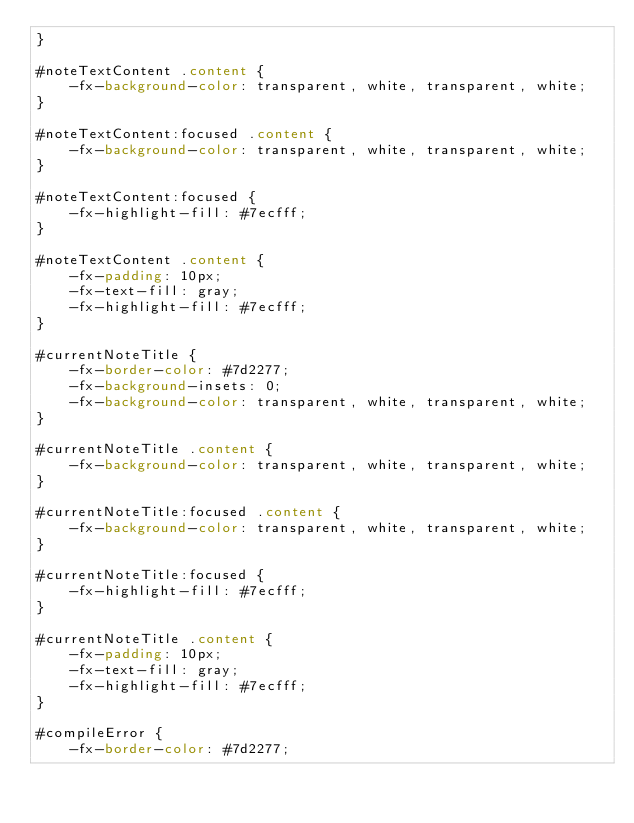<code> <loc_0><loc_0><loc_500><loc_500><_CSS_>}

#noteTextContent .content {
    -fx-background-color: transparent, white, transparent, white;
}

#noteTextContent:focused .content {
    -fx-background-color: transparent, white, transparent, white;
}

#noteTextContent:focused {
    -fx-highlight-fill: #7ecfff;
}

#noteTextContent .content {
    -fx-padding: 10px;
    -fx-text-fill: gray;
    -fx-highlight-fill: #7ecfff;
}

#currentNoteTitle {
    -fx-border-color: #7d2277;
    -fx-background-insets: 0;
    -fx-background-color: transparent, white, transparent, white;
}

#currentNoteTitle .content {
    -fx-background-color: transparent, white, transparent, white;
}

#currentNoteTitle:focused .content {
    -fx-background-color: transparent, white, transparent, white;
}

#currentNoteTitle:focused {
    -fx-highlight-fill: #7ecfff;
}

#currentNoteTitle .content {
    -fx-padding: 10px;
    -fx-text-fill: gray;
    -fx-highlight-fill: #7ecfff;
}

#compileError {
    -fx-border-color: #7d2277;</code> 